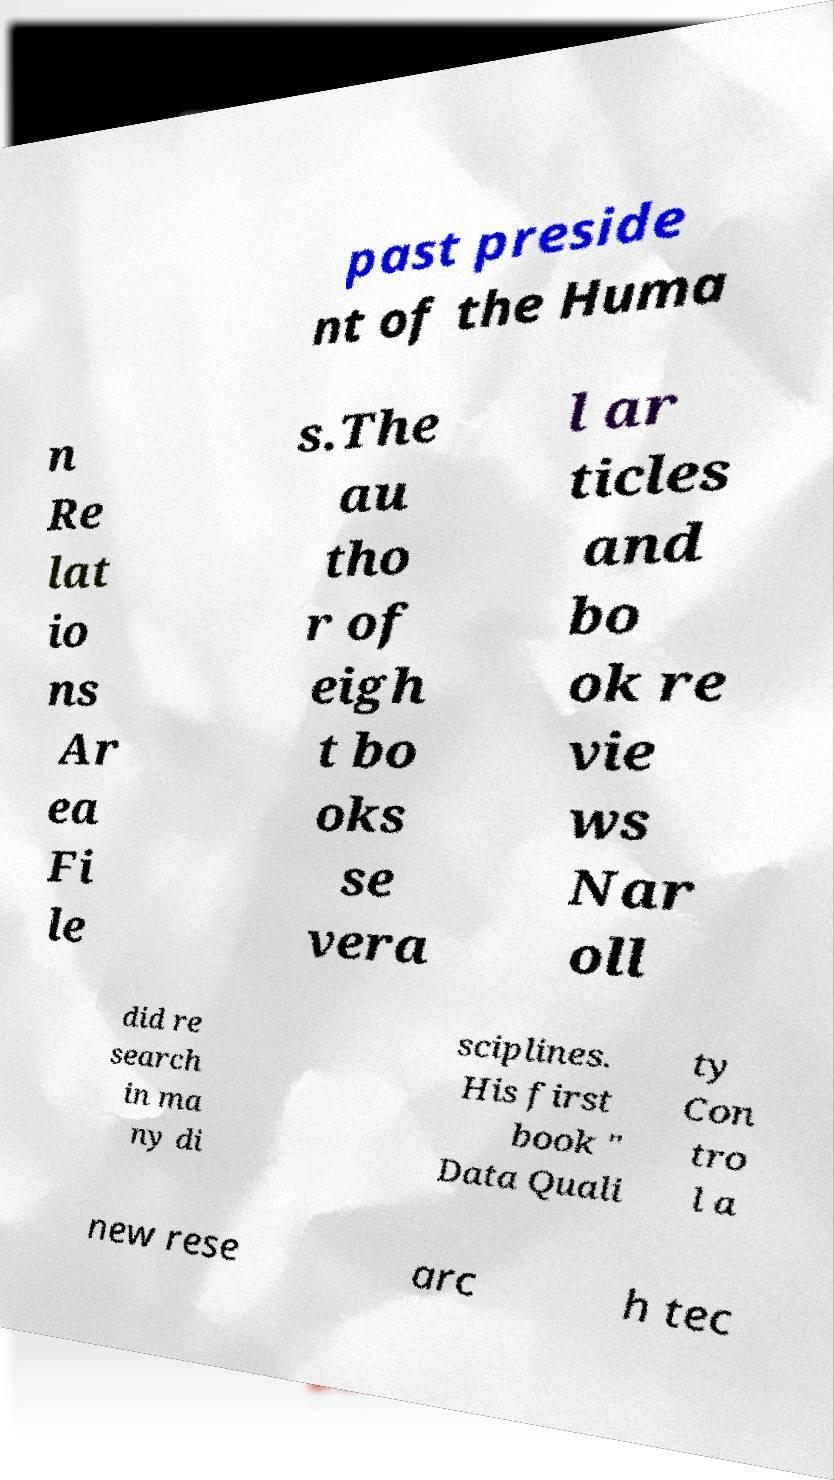Could you extract and type out the text from this image? past preside nt of the Huma n Re lat io ns Ar ea Fi le s.The au tho r of eigh t bo oks se vera l ar ticles and bo ok re vie ws Nar oll did re search in ma ny di sciplines. His first book " Data Quali ty Con tro l a new rese arc h tec 